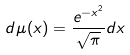<formula> <loc_0><loc_0><loc_500><loc_500>d \mu ( x ) = \frac { e ^ { - x ^ { 2 } } } { \sqrt { \pi } } d x</formula> 